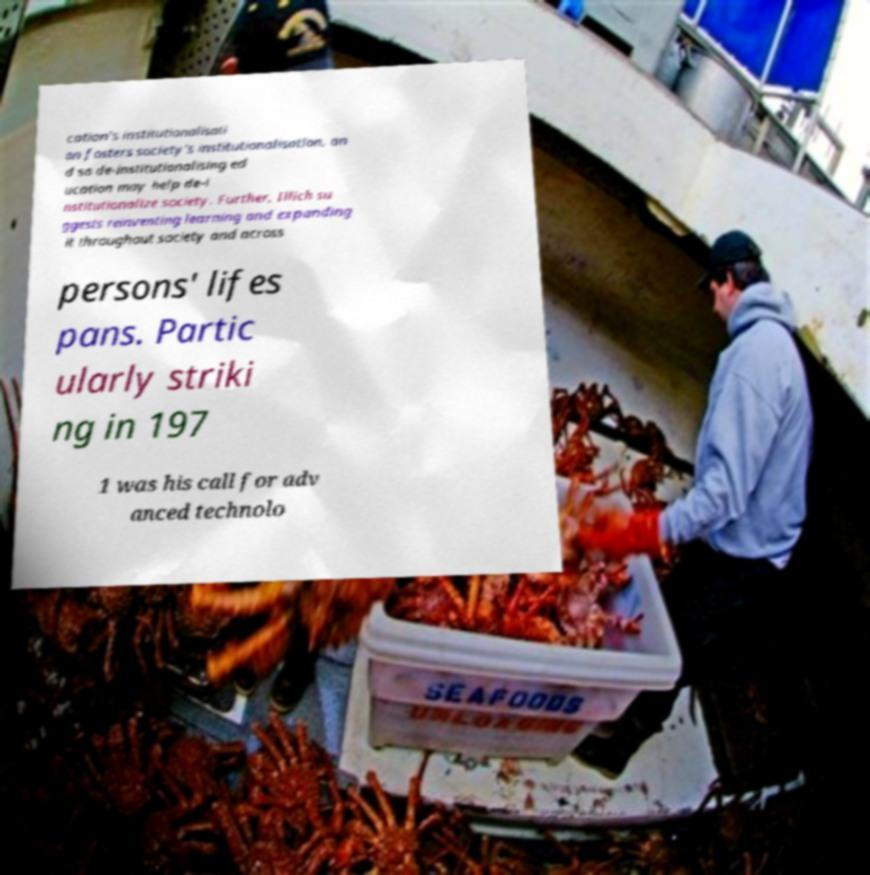What messages or text are displayed in this image? I need them in a readable, typed format. cation's institutionalisati on fosters society's institutionalisation, an d so de-institutionalising ed ucation may help de-i nstitutionalize society. Further, Illich su ggests reinventing learning and expanding it throughout society and across persons' lifes pans. Partic ularly striki ng in 197 1 was his call for adv anced technolo 